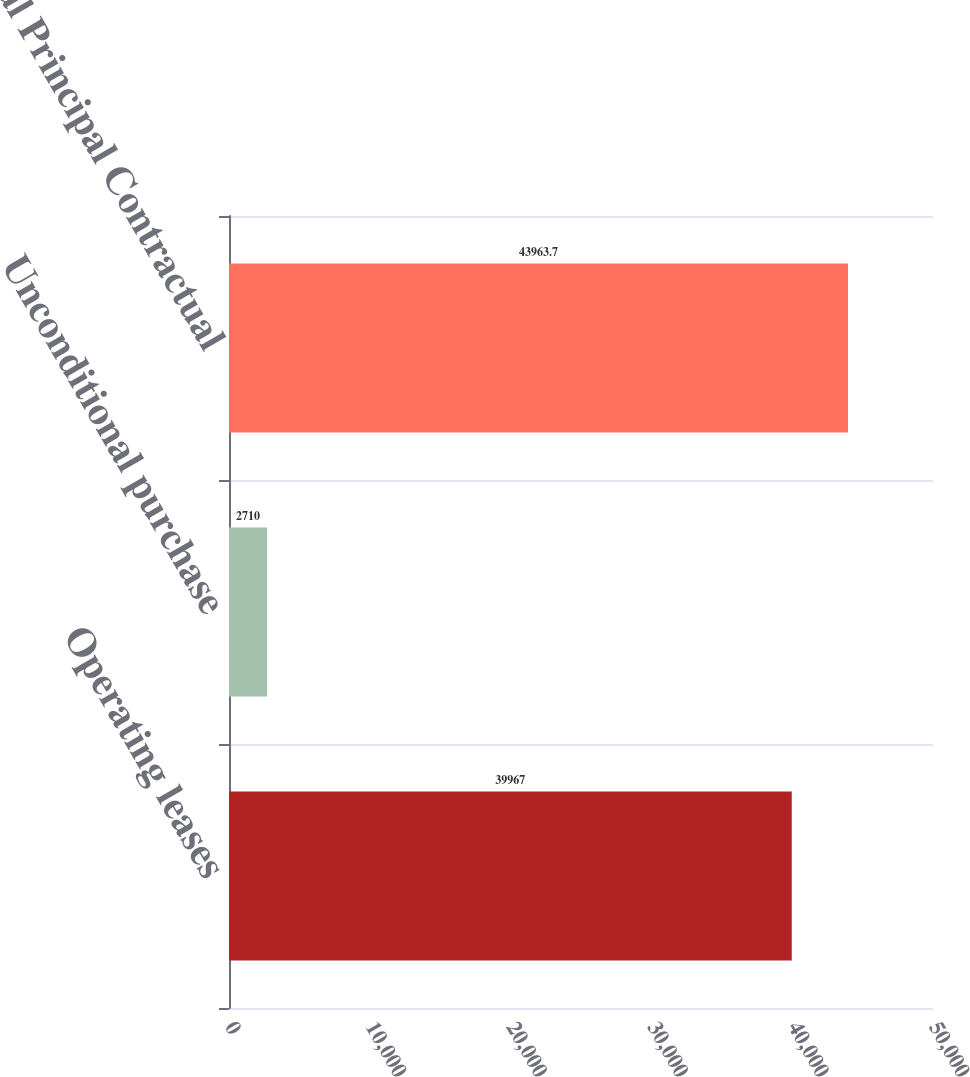<chart> <loc_0><loc_0><loc_500><loc_500><bar_chart><fcel>Operating leases<fcel>Unconditional purchase<fcel>Total Principal Contractual<nl><fcel>39967<fcel>2710<fcel>43963.7<nl></chart> 